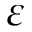Convert formula to latex. <formula><loc_0><loc_0><loc_500><loc_500>\varepsilon</formula> 